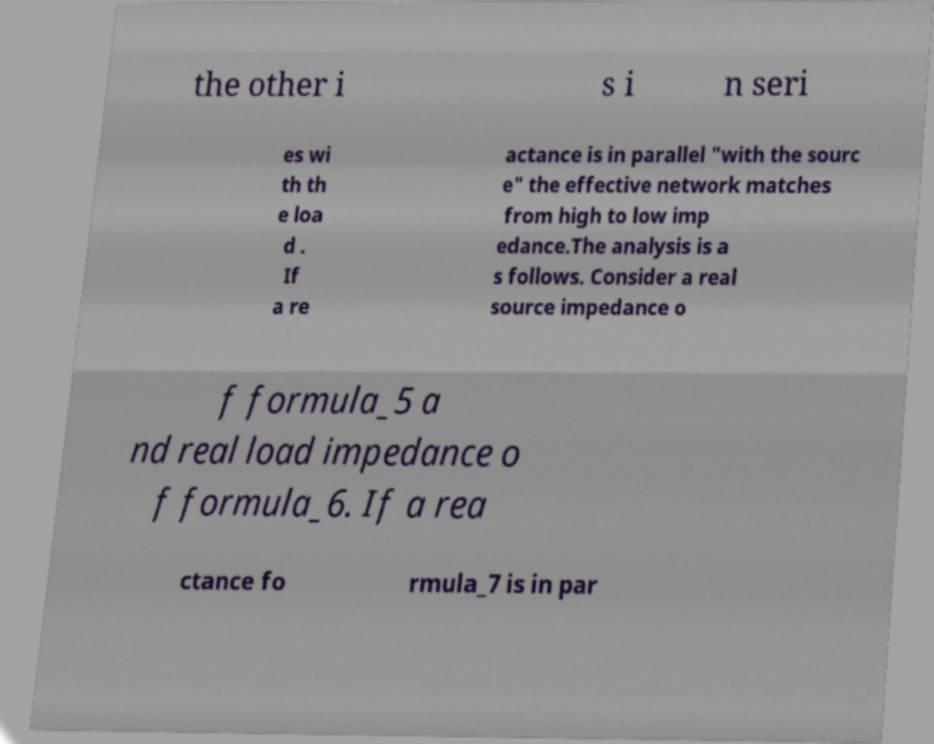Could you assist in decoding the text presented in this image and type it out clearly? the other i s i n seri es wi th th e loa d . If a re actance is in parallel "with the sourc e" the effective network matches from high to low imp edance.The analysis is a s follows. Consider a real source impedance o f formula_5 a nd real load impedance o f formula_6. If a rea ctance fo rmula_7 is in par 